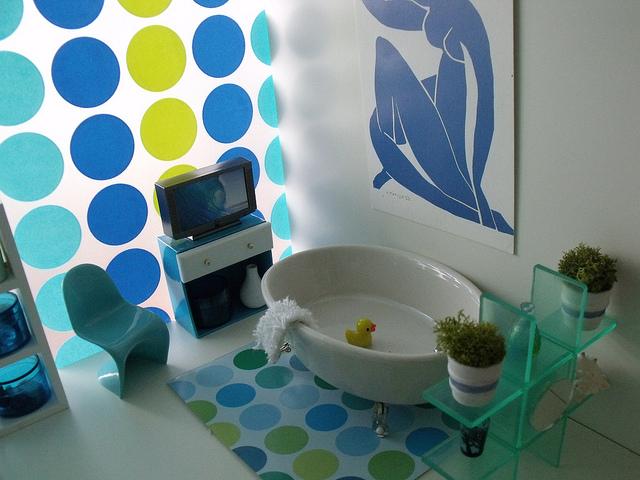What color is the mug?
Concise answer only. White. Are these flower stems?
Keep it brief. No. What is in the picture?
Concise answer only. Bathroom. What is in the video?
Short answer required. Duck. Is there a teddy bear on the left?
Quick response, please. No. What color is in all the pictures?
Concise answer only. Blue. What is floating in the bowl?
Give a very brief answer. Rubber duck. Can you eat these items?
Be succinct. No. What is the predominant color is the scene?
Concise answer only. Blue. What picture is hanging on the wall?
Keep it brief. Woman. Are these toys?
Write a very short answer. Yes. What is standing in the corner of the room?
Answer briefly. Tv. Is the food fresh?
Keep it brief. No. Is the water running?
Quick response, please. No. What color is this bathroom?
Short answer required. White. Is the room dark?
Write a very short answer. No. What is in the bathtub?
Be succinct. Rubber duck. Is there a candle lit?
Answer briefly. No. 